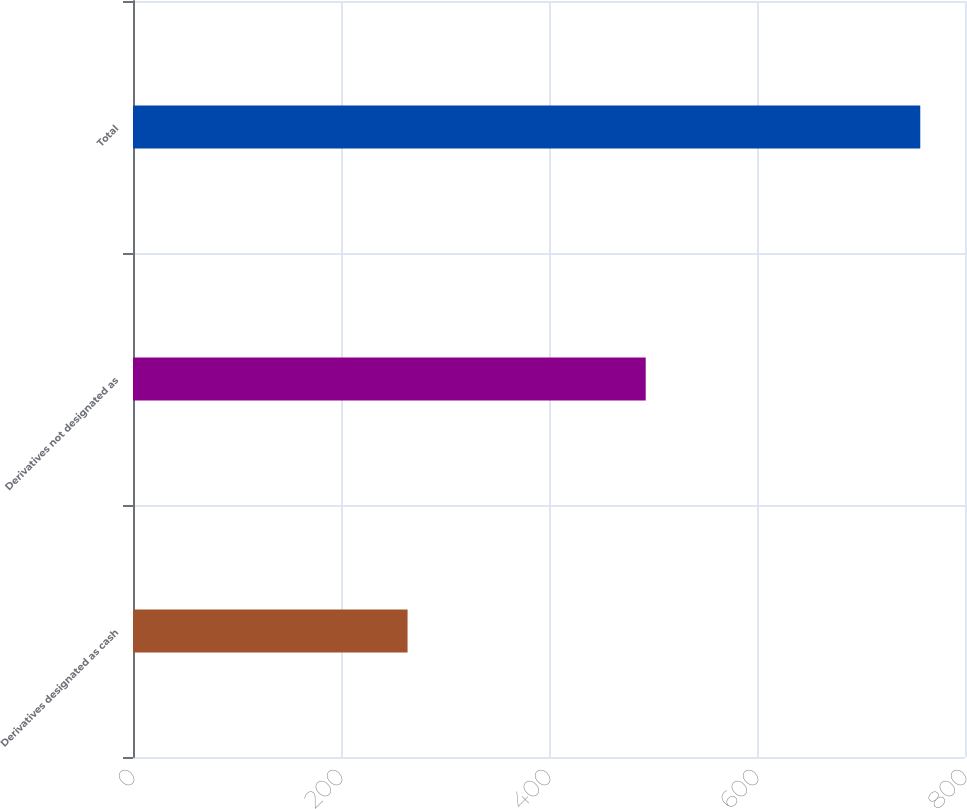<chart> <loc_0><loc_0><loc_500><loc_500><bar_chart><fcel>Derivatives designated as cash<fcel>Derivatives not designated as<fcel>Total<nl><fcel>264<fcel>493<fcel>757<nl></chart> 